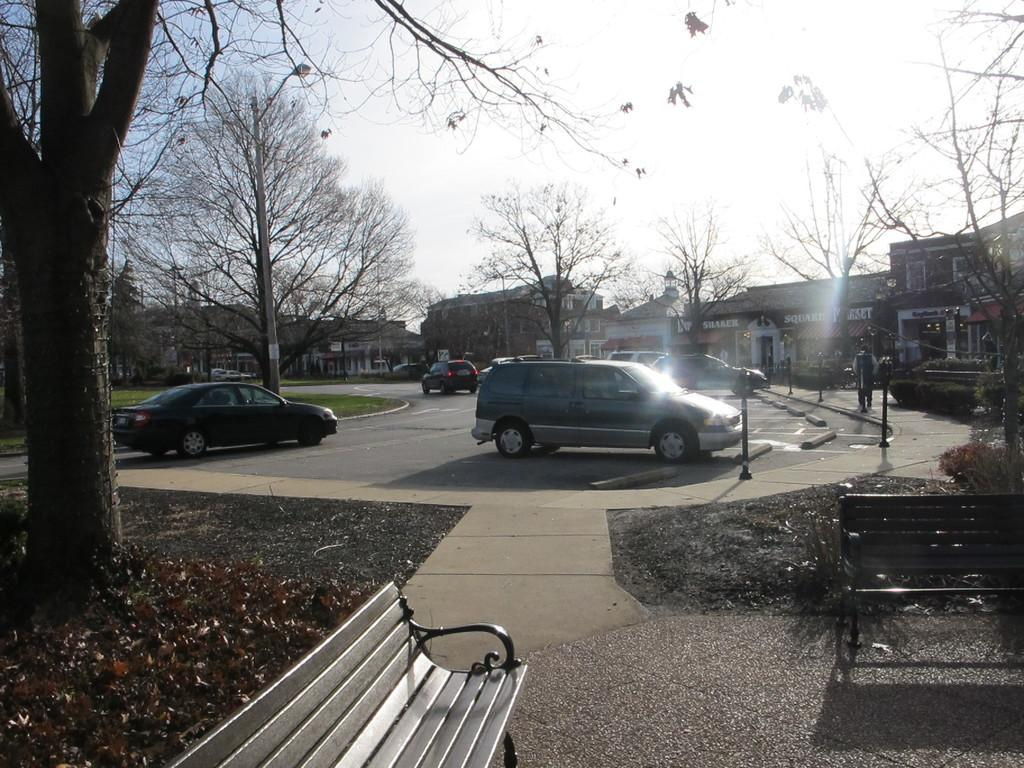What type of seating is visible in the image? There are benches in the image. What type of vehicles can be seen in the image? There are cars in the image. What type of structures are present in the image? There are buildings in the image. What type of vegetation is present in the image? There are trees in the image. What type of vertical structures are present in the image? There are poles in the image. What is the person in the image doing? A person is moving on the road in the image. What type of natural debris is present on the floor in the image? Dry leaves are present on the floor to the left side of the image. Can you tell me how many basketballs are visible in the image? There are no basketballs present in the image. What type of industry is depicted in the image? The image does not depict any specific industry; it contains benches, cars, buildings, trees, poles, a person moving on the road, and dry leaves on the floor. 